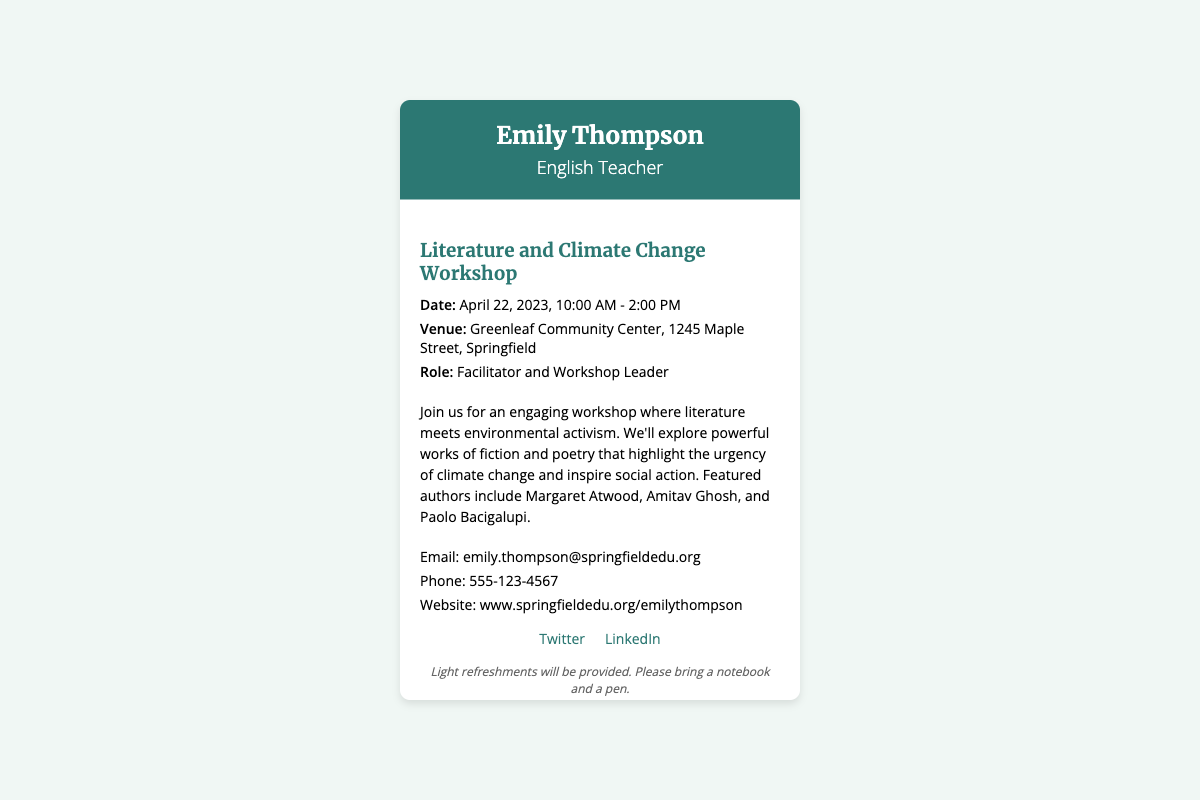What is the name of the facilitator? The facilitator's name is mentioned in the header of the document.
Answer: Emily Thompson What is the date of the workshop? The date of the workshop is specified in the event details section.
Answer: April 22, 2023 What is the venue for the workshop? The venue is listed in the event details part of the document.
Answer: Greenleaf Community Center What time does the workshop start? The start time is included in the event details.
Answer: 10:00 AM Which authors are featured in the workshop? The authors are highlighted in the description of the workshop.
Answer: Margaret Atwood, Amitav Ghosh, and Paolo Bacigalupi What type of event is this document referring to? The title and header of the card indicate the nature of the event.
Answer: Workshop What should participants bring to the workshop? The additional info section suggests what participants should bring.
Answer: Notebook and a pen What contact method is provided for further inquiries? The document lists multiple contact methods in the contact info section.
Answer: Email Is there a provision for refreshments? The additional information section notes the availability of refreshments.
Answer: Yes 